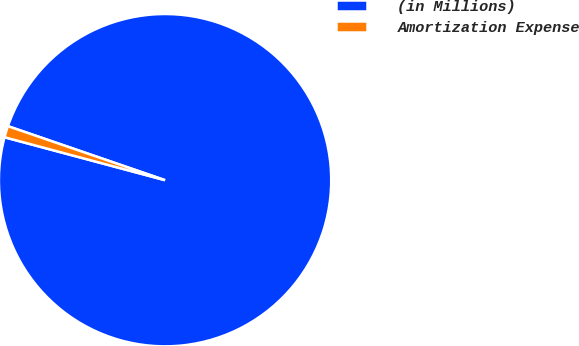<chart> <loc_0><loc_0><loc_500><loc_500><pie_chart><fcel>(in Millions)<fcel>Amortization Expense<nl><fcel>98.89%<fcel>1.11%<nl></chart> 